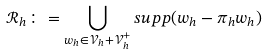Convert formula to latex. <formula><loc_0><loc_0><loc_500><loc_500>\mathcal { R } _ { h } \colon = \bigcup _ { w _ { h } \in \mathcal { V } _ { h } + \mathcal { V } _ { h } ^ { + } } s u p p ( w _ { h } - \pi _ { h } w _ { h } )</formula> 